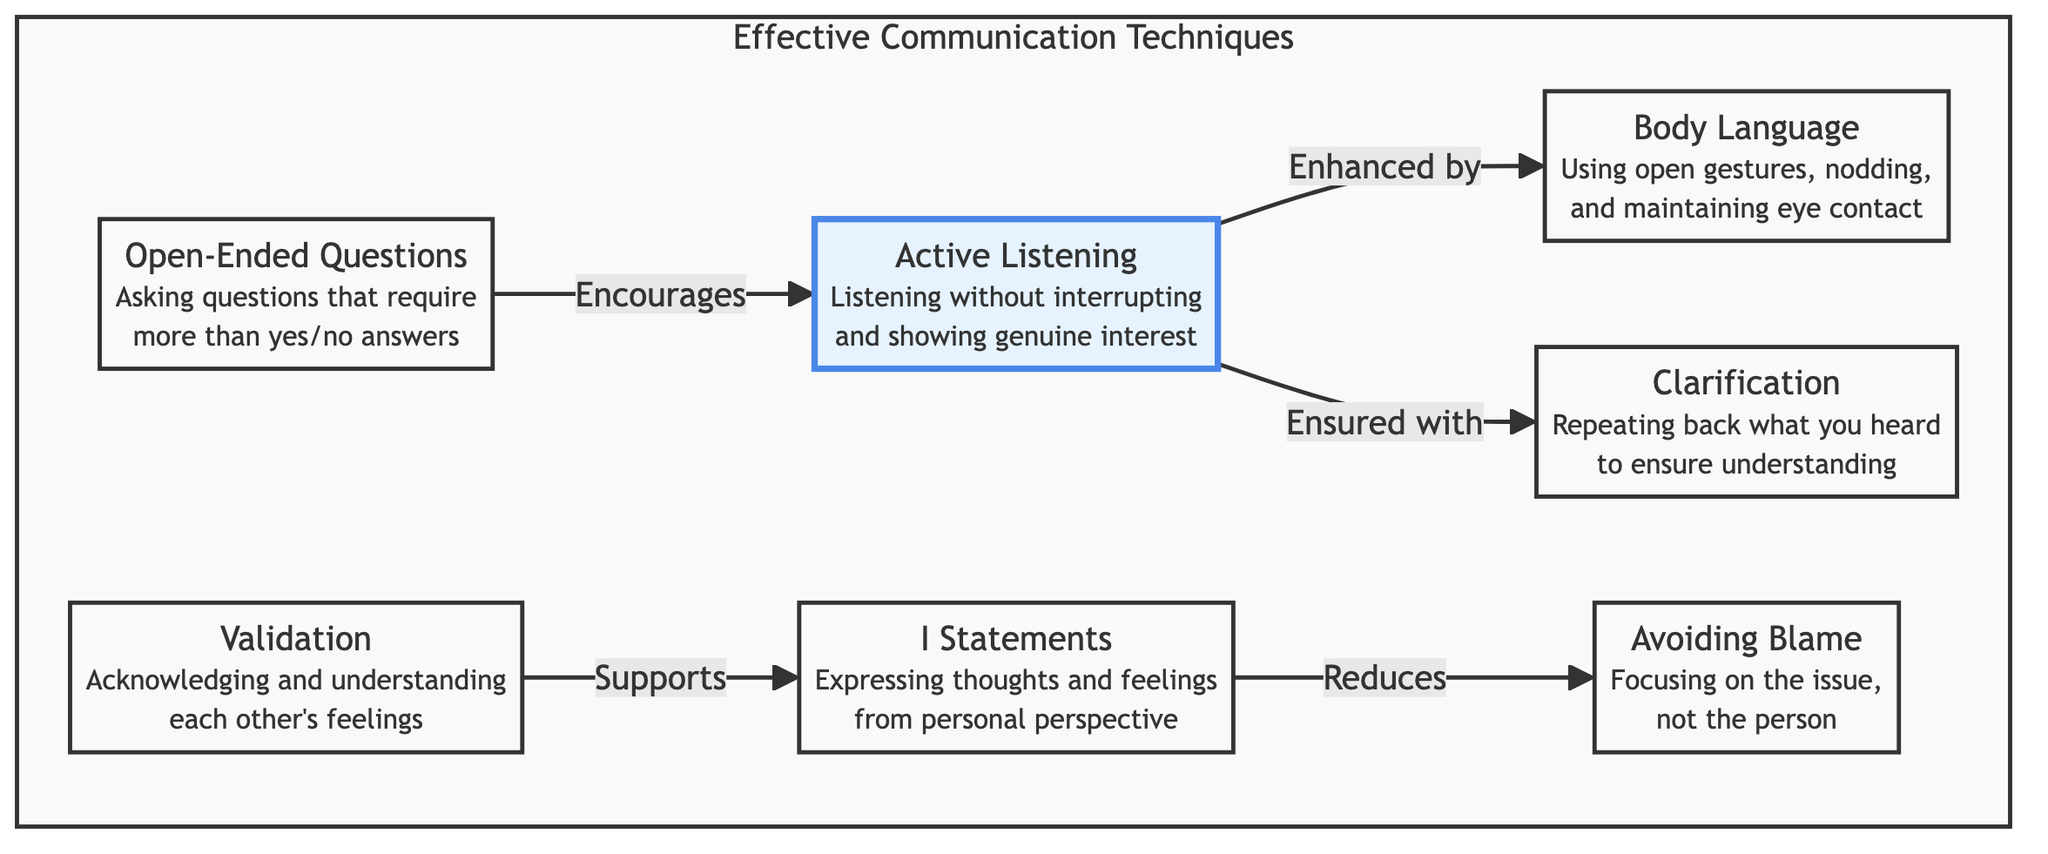What are two techniques that enhance Active Listening? The diagram shows that Body Language and Clarification are both connected to Active Listening. Body Language enhances Active Listening, while Clarification ensures it.
Answer: Body Language, Clarification How many total techniques are identified in the diagram? Counting the nodes, there are a total of seven techniques listed under Effective Communication Techniques.
Answer: 7 What type of question does Open-Ended Questions encourage? The diagram indicates that Open-Ended Questions encourages Active Listening. This connection shows that asking these types of questions leads to enhanced listening experiences.
Answer: Active Listening Which technique is highlighted in the diagram? The only technique emphasized in the diagram is Active Listening, distinguished by the highlighted style applied to it.
Answer: Active Listening What do Validation and I Statements support and reduce, respectively? Validation supports I Statements while I Statements reduce Avoiding Blame. This indicates a relationship of support and a corrective impact in the communication process.
Answer: Support I Statements, Reduce Avoiding Blame What is a key purpose of Clarification in communication? Clarification is intended to ensure understanding by repeating back what you heard. This process helps confirm whether the message has been accurately received.
Answer: Ensure understanding 